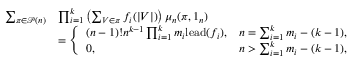Convert formula to latex. <formula><loc_0><loc_0><loc_500><loc_500>\begin{array} { r l } { \sum _ { \pi \in \mathcal { P } ( n ) } } & { \prod _ { i = 1 } ^ { k } \left ( \sum _ { V \in \pi } f _ { i } ( | V | ) \right ) \mu _ { n } ( \pi , 1 _ { n } ) } \\ & { = \left \{ \begin{array} { l l } { ( n - 1 ) ! n ^ { k - 1 } \prod _ { i = 1 } ^ { k } m _ { i } l e a d ( f _ { i } ) , } & { n = \sum _ { i = 1 } ^ { k } m _ { i } - ( k - 1 ) , } \\ { 0 , } & { n > \sum _ { i = 1 } ^ { k } m _ { i } - ( k - 1 ) , } \end{array} } \end{array}</formula> 